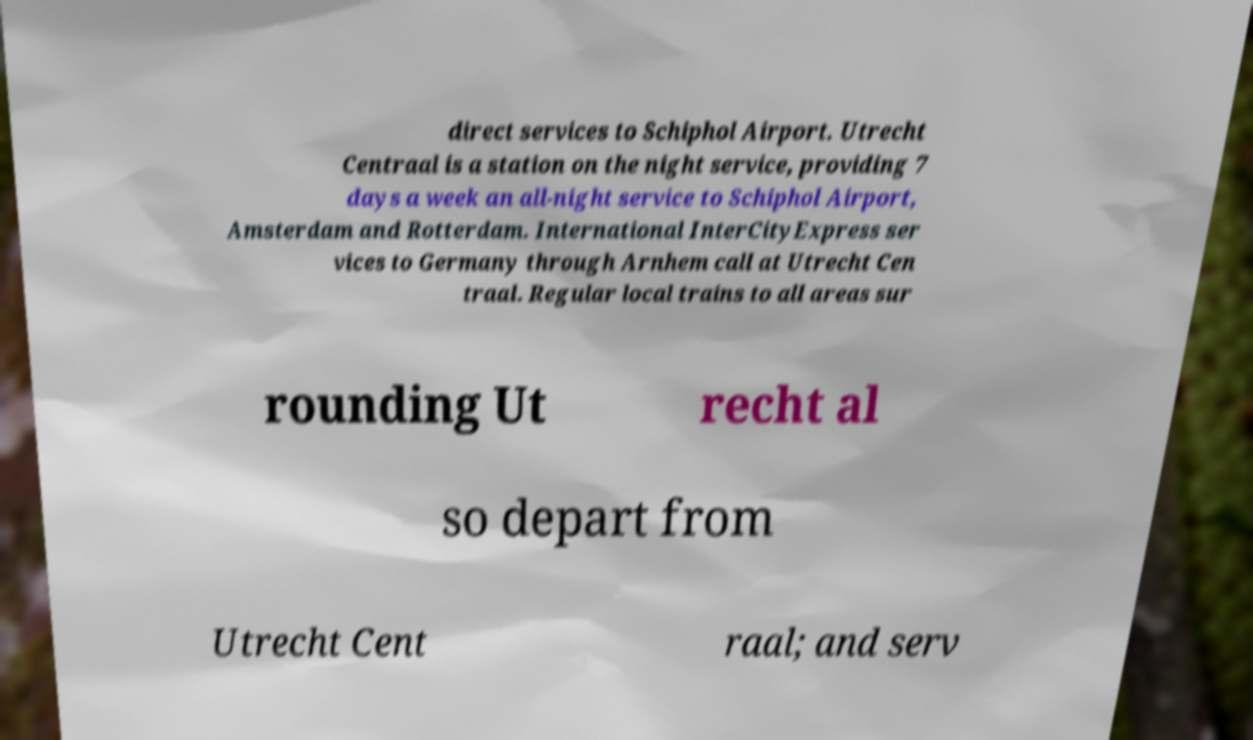Can you accurately transcribe the text from the provided image for me? direct services to Schiphol Airport. Utrecht Centraal is a station on the night service, providing 7 days a week an all-night service to Schiphol Airport, Amsterdam and Rotterdam. International InterCityExpress ser vices to Germany through Arnhem call at Utrecht Cen traal. Regular local trains to all areas sur rounding Ut recht al so depart from Utrecht Cent raal; and serv 